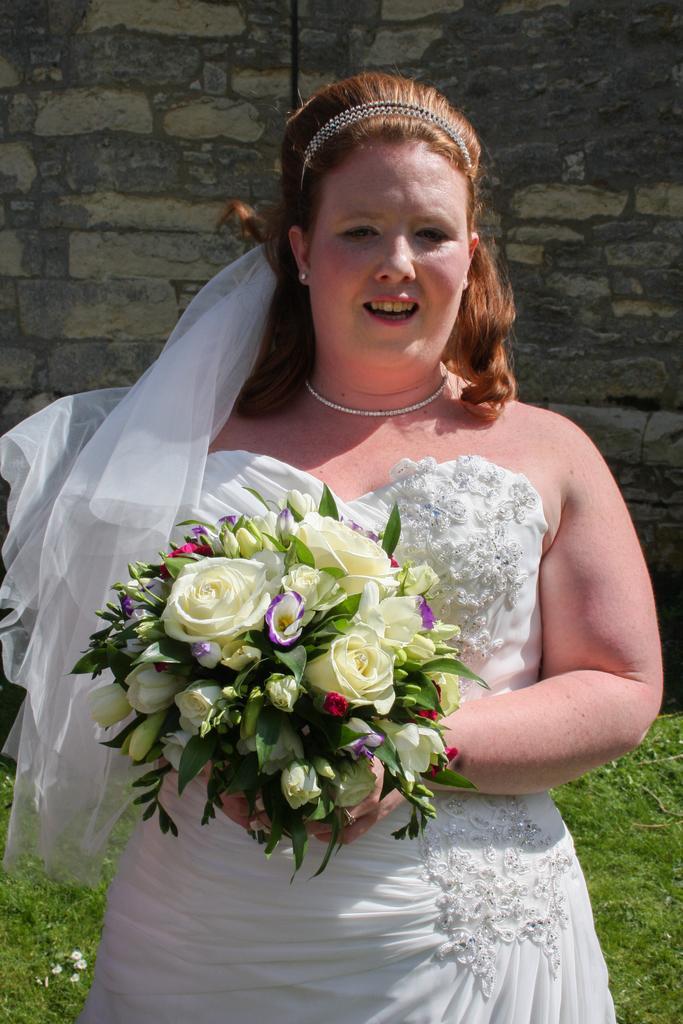Can you describe this image briefly? In this image we can see a lady holding a flower bouquet, also we can see the grass, and the wall. 